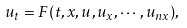Convert formula to latex. <formula><loc_0><loc_0><loc_500><loc_500>u _ { t } = F ( t , x , u , u _ { x } , \cdots , u _ { n x } ) ,</formula> 